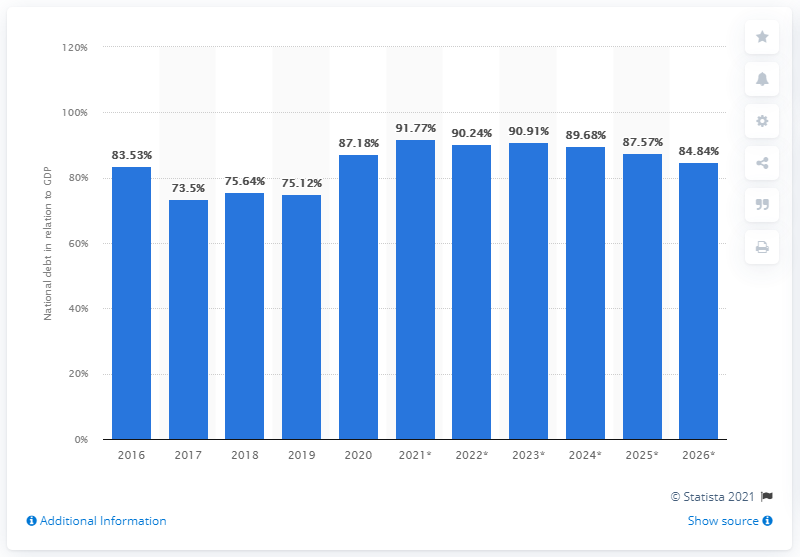Give some essential details in this illustration. In 2020, the national debt of St. Vincent and the Grenadines was approximately 87.57% of the country's GDP. 